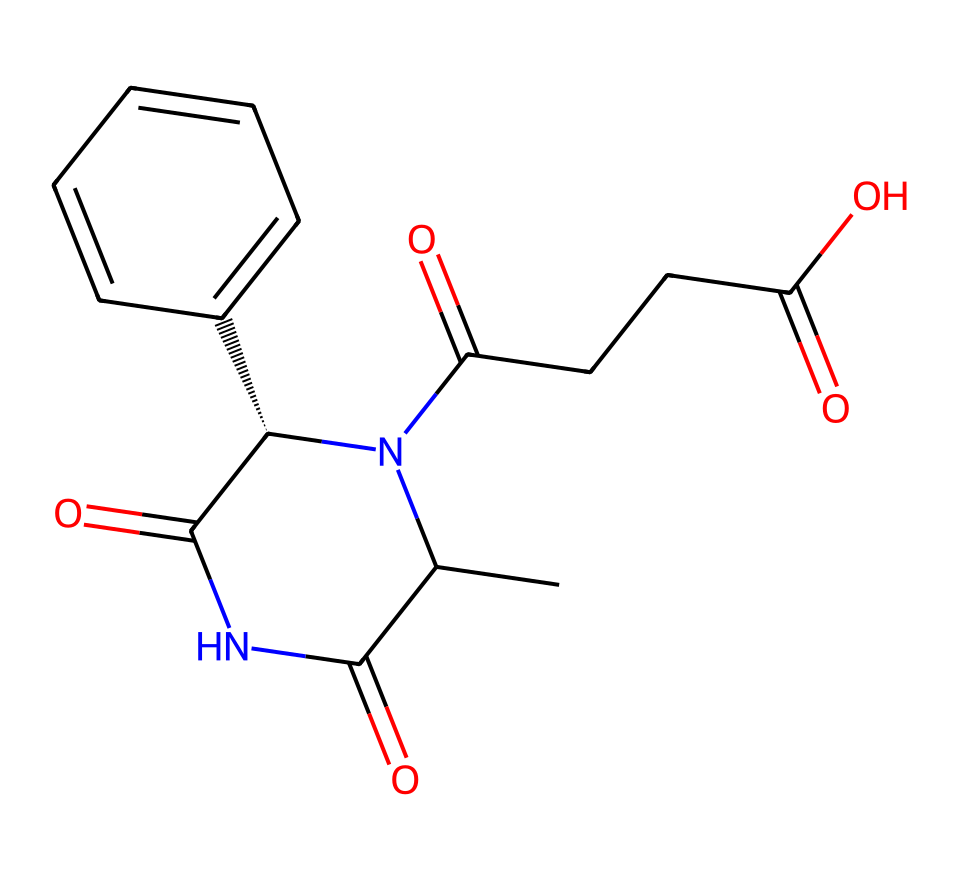What is the molecular formula of thalidomide? To find the molecular formula, count the number of each type of atom present in the SMILES representation: C (carbon), H (hydrogen), N (nitrogen), and O (oxygen). By parsing the SMILES, we find there are 13 carbons, 13 hydrogens, 3 nitrogens, and 4 oxygens. Therefore, the molecular formula is C13H13N3O4.
Answer: C13H13N3O4 How many chiral centers are present in thalidomide? A chiral center is identified by examining the carbon atoms connected to four different substituents. In this compound, there is one carbon atom designated with @ symbol in the SMILES, indicating a chiral center. Thus, thalidomide has one chiral center.
Answer: 1 What types of functional groups are found in thalidomide? Analyzing the SMILES, we can identify several functional groups like amides (indicated by the -C(=O)N- and N-C=O segments), a carboxylic acid (-COOH), and a ketone (-C(=O)-). Thus, thalidomide contains amides, a carboxylic acid, and ketones.
Answer: amides, carboxylic acid, ketones What is the stereochemistry associated with thalidomide? The chirality indicated by the @ symbol suggests that there is a specific three-dimensional arrangement around the chiral center, affecting the molecule's properties and interactions. The stereochemistry here is based on the spatial arrangement dictated by that chirality.
Answer: R or S (context-dependent) How does the chiral nature of thalidomide relate to its effects? Thalidomide exists as two enantiomers: one that is therapeutically beneficial and another that causes severe birth defects. The presence of one chiral center leads to this differentiation in biological activity. Thus, the chiral nature is pivotal in its effects.
Answer: enantiomers What historical impact did thalidomide have on drug regulations? The thalidomide tragedy, where the drug caused birth defects, led to more stringent drug testing and safety regulations to ensure similar incidents don’t occur in the future. This has significantly shaped modern drug approval processes.
Answer: stricter regulations 